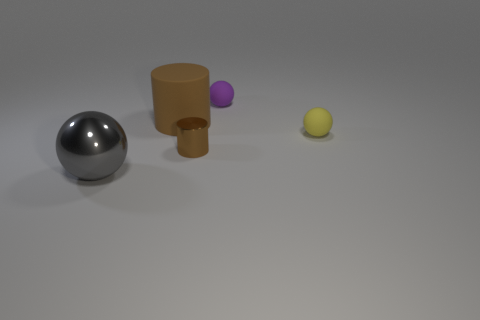Add 4 big blue cylinders. How many objects exist? 9 Subtract all balls. How many objects are left? 2 Add 3 yellow things. How many yellow things exist? 4 Subtract 0 brown blocks. How many objects are left? 5 Subtract all small purple objects. Subtract all green objects. How many objects are left? 4 Add 2 large things. How many large things are left? 4 